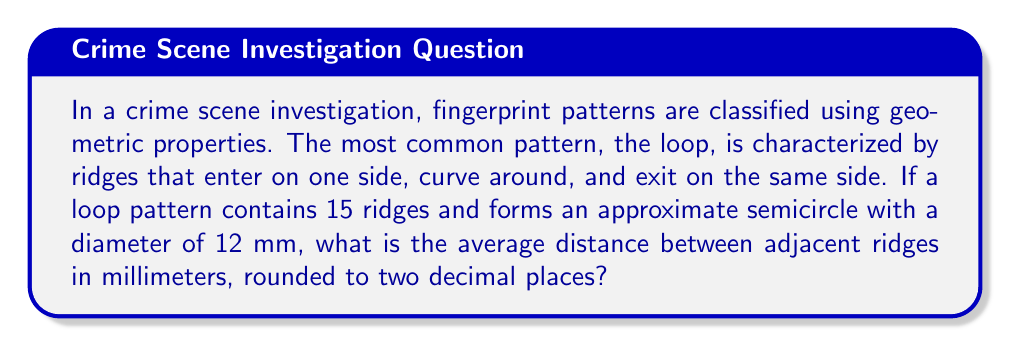Could you help me with this problem? To solve this problem, we need to follow these steps:

1) First, recall that the circumference of a semicircle is given by the formula:
   
   $$C = \frac{\pi d}{2}$$
   
   where $d$ is the diameter.

2) Given the diameter is 12 mm, we can calculate the semicircle's circumference:
   
   $$C = \frac{\pi \cdot 12}{2} = 6\pi \approx 18.85 \text{ mm}$$

3) Now, we know that there are 15 ridges along this length. To find the average distance between ridges, we need to divide the total length by the number of spaces between ridges.

4) The number of spaces between 15 ridges is 14 (always one less than the number of ridges).

5) So, the average distance between ridges is:
   
   $$\text{Average distance} = \frac{6\pi}{14} \approx 1.3464 \text{ mm}$$

6) Rounding to two decimal places gives us 1.35 mm.
Answer: 1.35 mm 